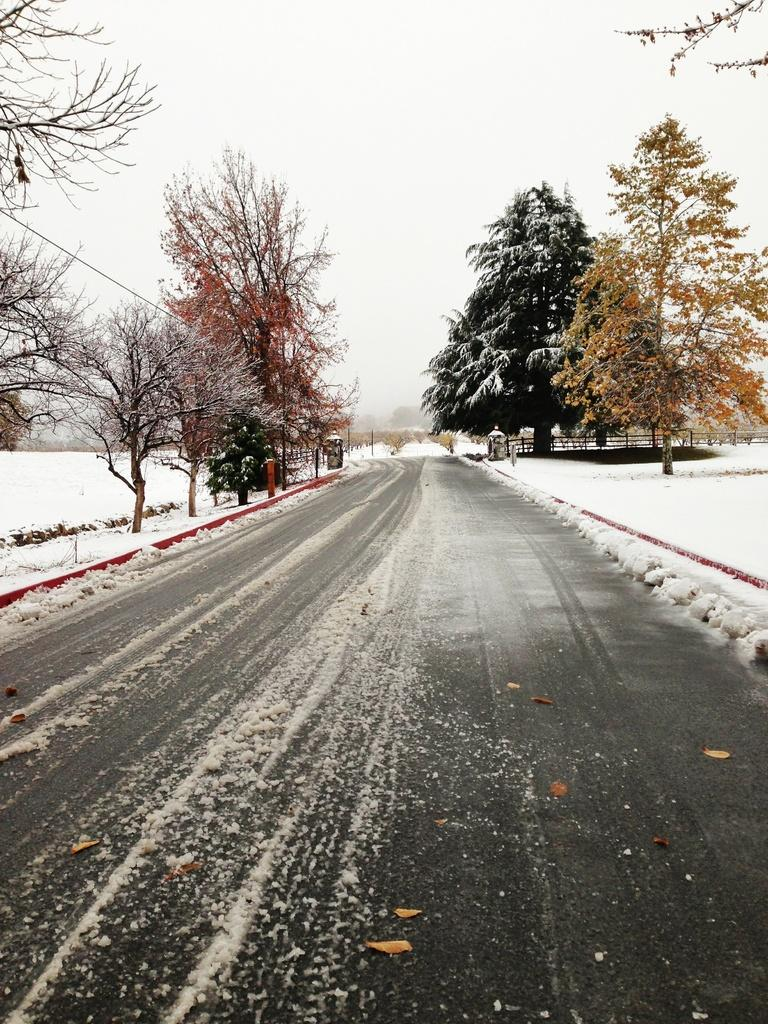What is the main subject of the image? The main subject of the image is an empty road. What can be seen on both sides of the road? There is snow on both sides of the road. What type of vegetation is visible in the image? There are trees visible in the image. What is visible above the road and trees? The sky is visible in the image. What type of pest can be seen crawling on the trees in the image? There are no pests visible in the image; it only shows an empty road, snow, trees, and the sky. 